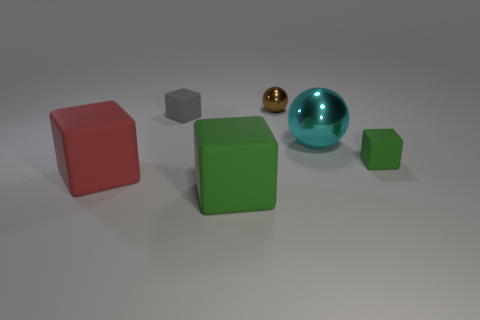Subtract 3 cubes. How many cubes are left? 1 Add 1 big cyan shiny objects. How many objects exist? 7 Subtract all brown spheres. How many spheres are left? 1 Subtract all red matte cubes. How many cubes are left? 3 Subtract 0 yellow cylinders. How many objects are left? 6 Subtract all balls. How many objects are left? 4 Subtract all brown balls. Subtract all blue blocks. How many balls are left? 1 Subtract all purple spheres. How many gray cubes are left? 1 Subtract all large shiny cubes. Subtract all green matte cubes. How many objects are left? 4 Add 6 tiny brown metal spheres. How many tiny brown metal spheres are left? 7 